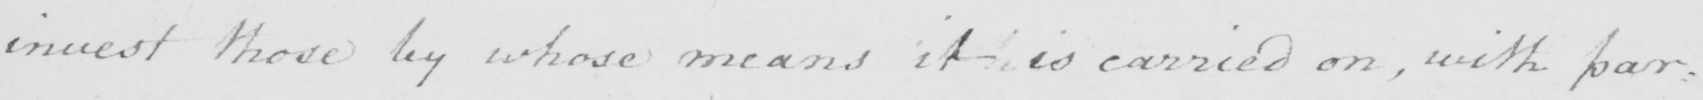What text is written in this handwritten line? invest those by whose means it is carried on , with par= 